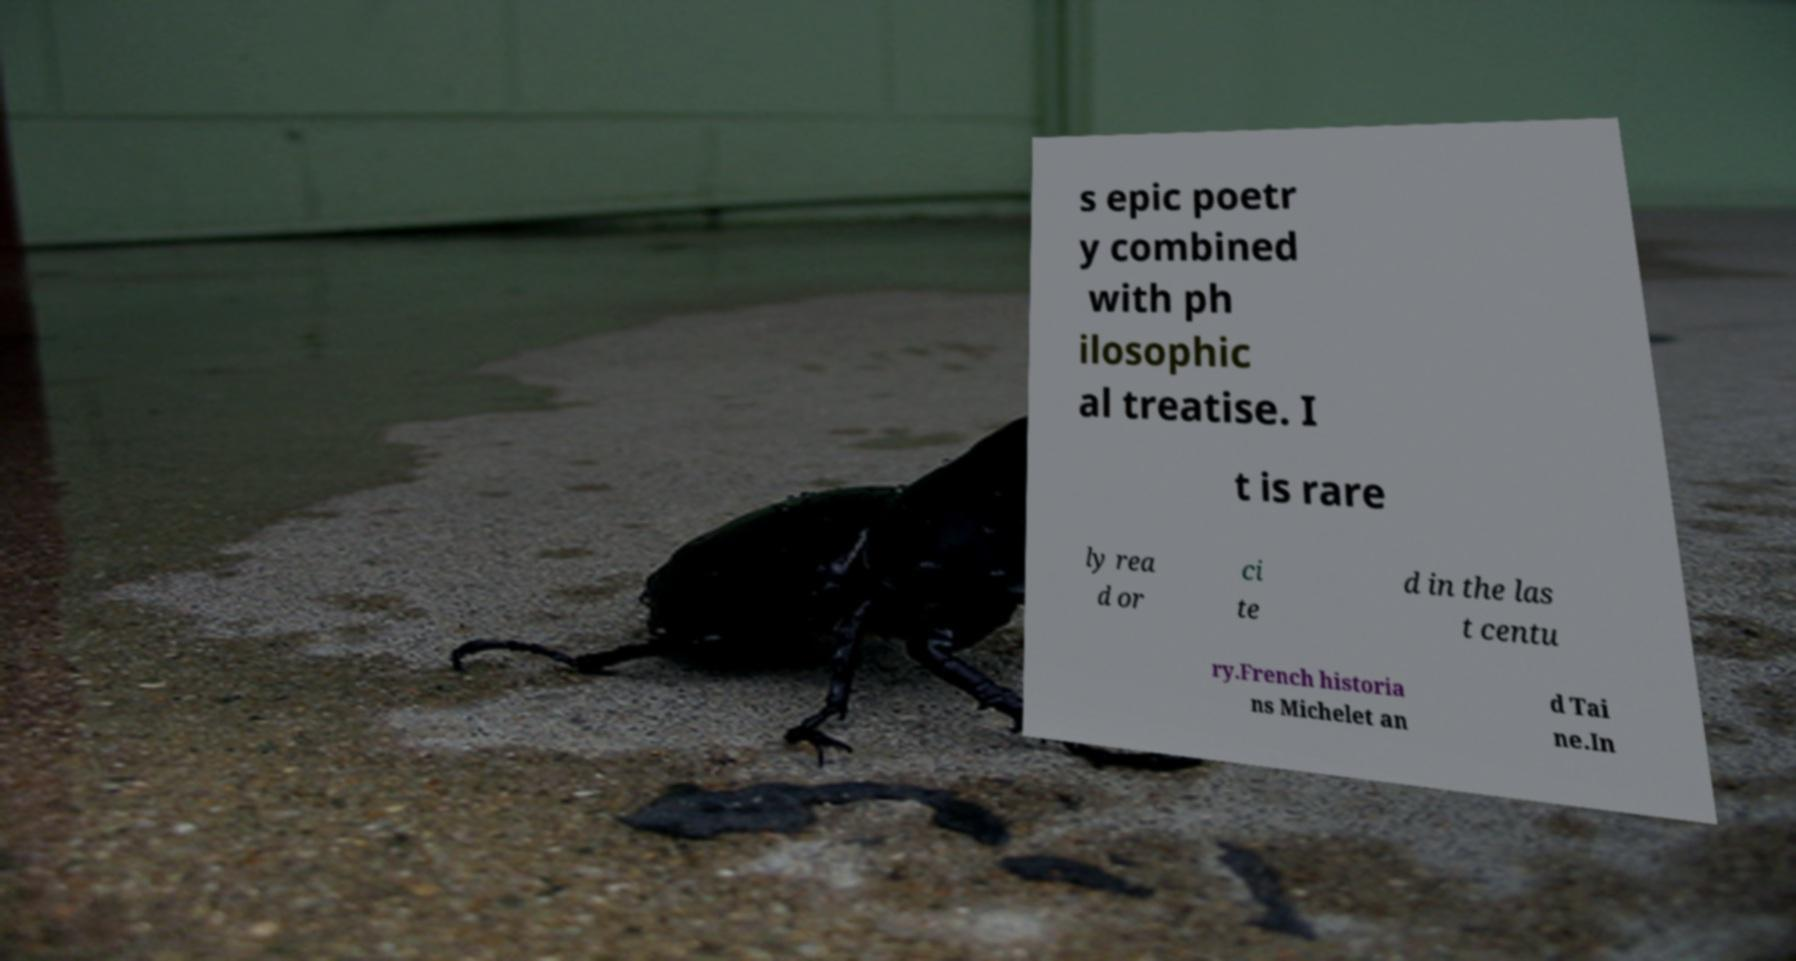For documentation purposes, I need the text within this image transcribed. Could you provide that? s epic poetr y combined with ph ilosophic al treatise. I t is rare ly rea d or ci te d in the las t centu ry.French historia ns Michelet an d Tai ne.In 